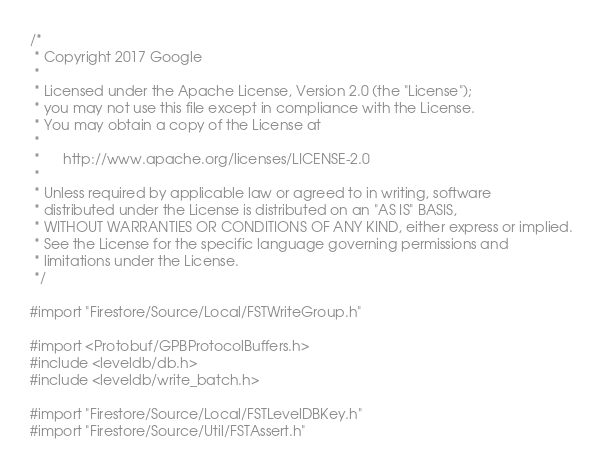Convert code to text. <code><loc_0><loc_0><loc_500><loc_500><_ObjectiveC_>/*
 * Copyright 2017 Google
 *
 * Licensed under the Apache License, Version 2.0 (the "License");
 * you may not use this file except in compliance with the License.
 * You may obtain a copy of the License at
 *
 *      http://www.apache.org/licenses/LICENSE-2.0
 *
 * Unless required by applicable law or agreed to in writing, software
 * distributed under the License is distributed on an "AS IS" BASIS,
 * WITHOUT WARRANTIES OR CONDITIONS OF ANY KIND, either express or implied.
 * See the License for the specific language governing permissions and
 * limitations under the License.
 */

#import "Firestore/Source/Local/FSTWriteGroup.h"

#import <Protobuf/GPBProtocolBuffers.h>
#include <leveldb/db.h>
#include <leveldb/write_batch.h>

#import "Firestore/Source/Local/FSTLevelDBKey.h"
#import "Firestore/Source/Util/FSTAssert.h"
</code> 